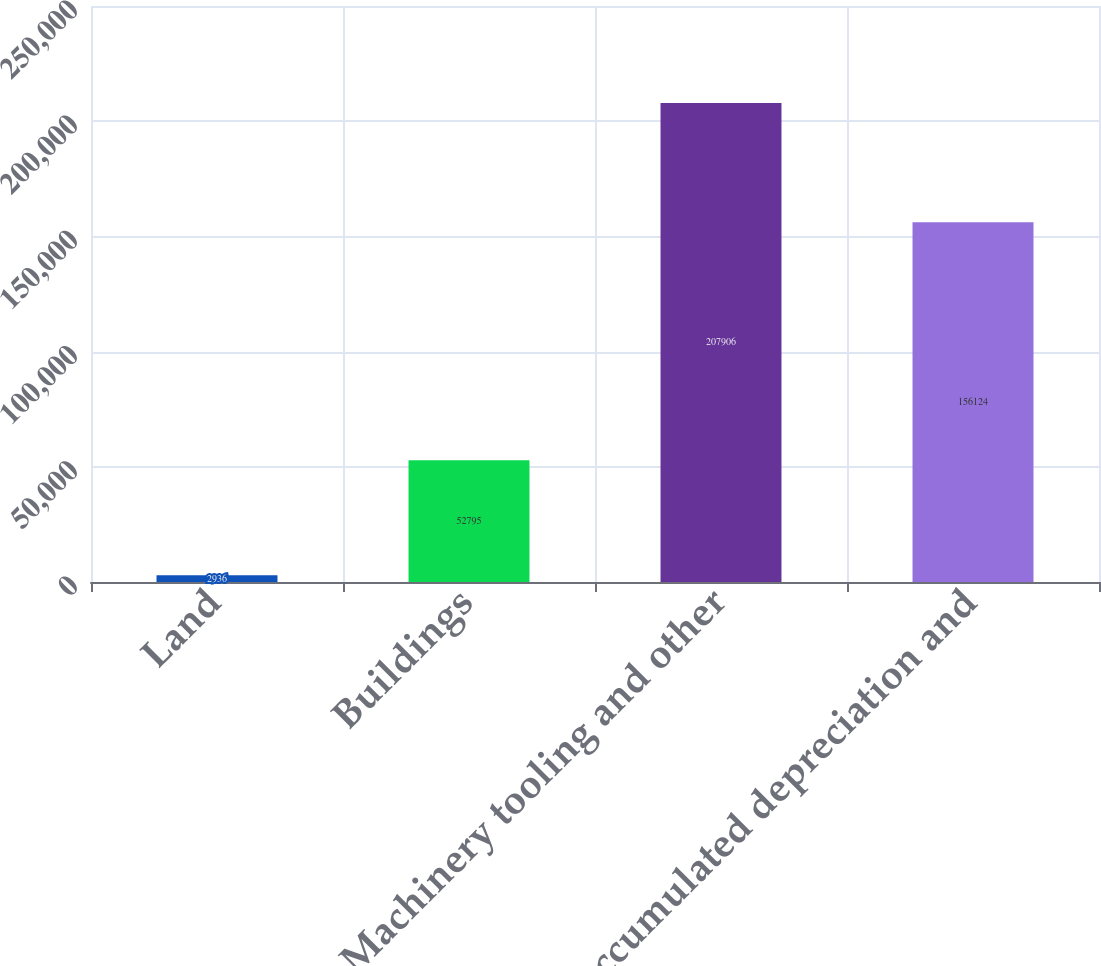Convert chart. <chart><loc_0><loc_0><loc_500><loc_500><bar_chart><fcel>Land<fcel>Buildings<fcel>Machinery tooling and other<fcel>Accumulated depreciation and<nl><fcel>2936<fcel>52795<fcel>207906<fcel>156124<nl></chart> 